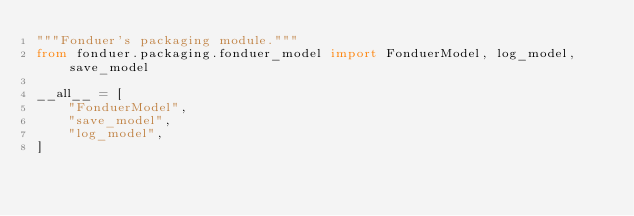Convert code to text. <code><loc_0><loc_0><loc_500><loc_500><_Python_>"""Fonduer's packaging module."""
from fonduer.packaging.fonduer_model import FonduerModel, log_model, save_model

__all__ = [
    "FonduerModel",
    "save_model",
    "log_model",
]
</code> 